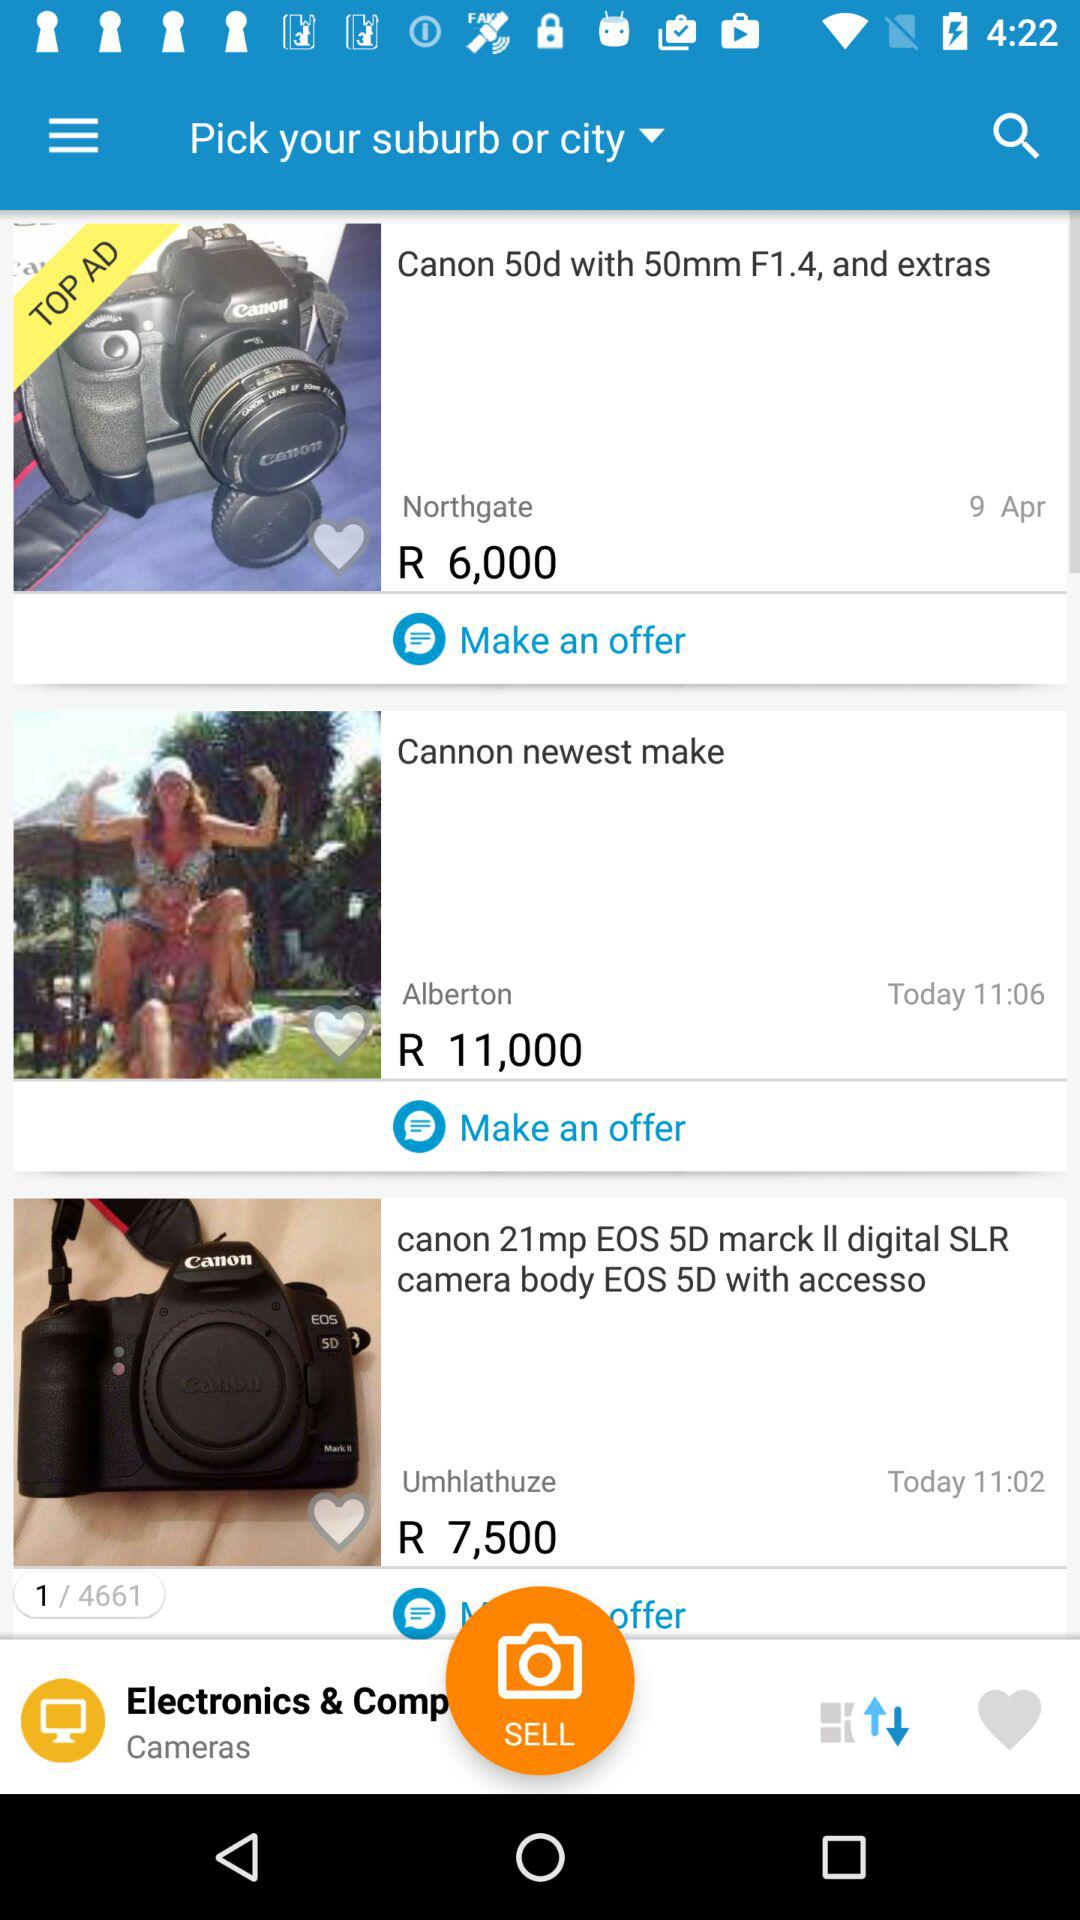How many items are there with a price less than 10,000?
Answer the question using a single word or phrase. 2 